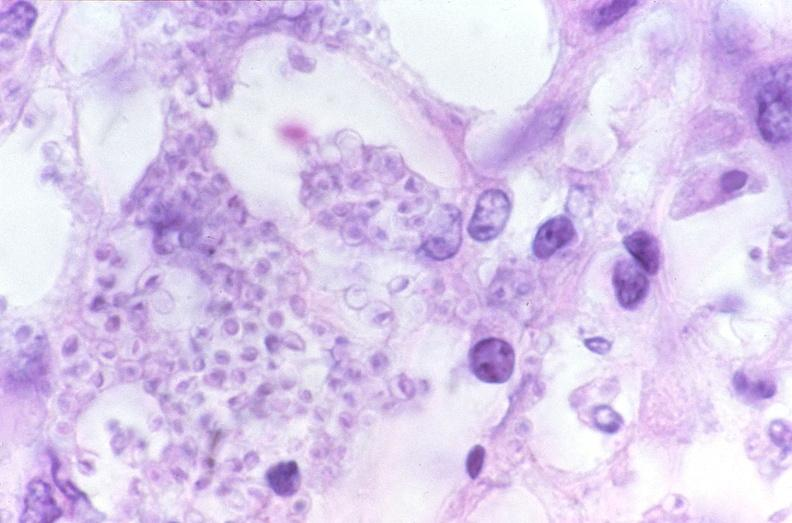where is this?
Answer the question using a single word or phrase. Lung 